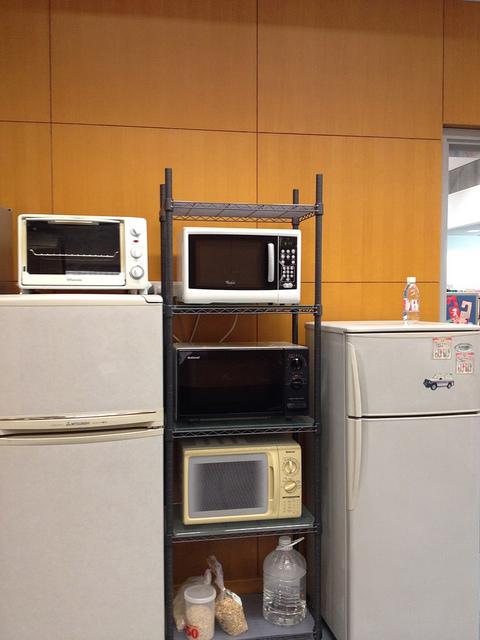How many refrigerators are there?
Keep it brief. 2. What beverage is on top of the refrigerator?
Write a very short answer. Water. Is there a stove in this photo?
Give a very brief answer. No. What color is the wall?
Keep it brief. Orange. What is on the fridge?
Concise answer only. Microwave. 